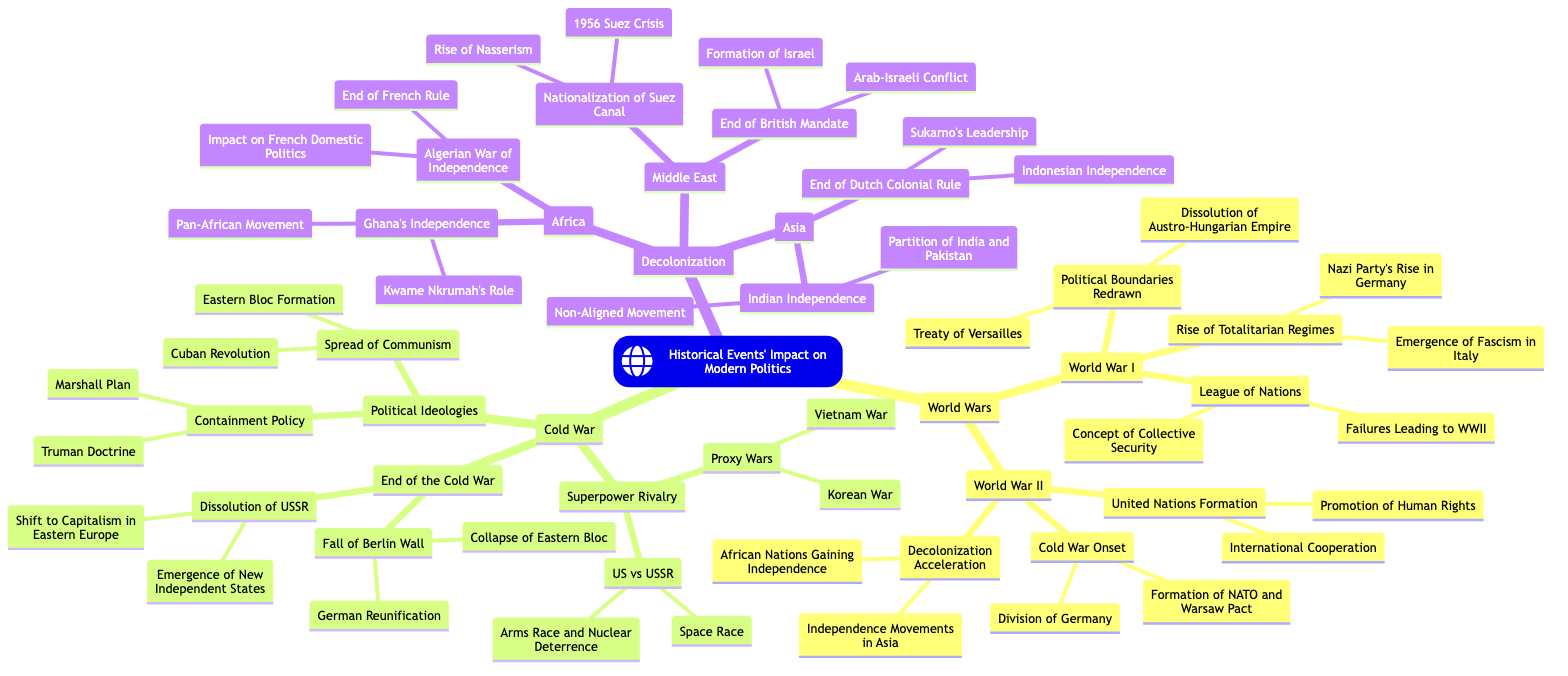What major treaty followed World War I? The diagram mentions that the "Treaty of Versailles" was a significant outcome of World War I under the branch "Political Boundaries Redrawn."
Answer: Treaty of Versailles What led to the formation of the United Nations? The diagram lists that the "United Nations Formation" was an outcome of World War II focusing on "International Cooperation" and the "Promotion of Human Rights."
Answer: United Nations Formation Which ideology spread significantly during the Cold War? The diagram states "Spread of Communism" as one of the key political ideologies during the Cold War.
Answer: Spread of Communism What was a major consequence of the dissolution of the USSR? The diagram indicates that the "Emergence of New Independent States" is a significant impact of the "Dissolution of USSR" in the context of the end of the Cold War.
Answer: Emergence of New Independent States How many major areas are covered under Decolonization? The diagram shows three main branches under Decolonization: Asia, Africa, and Middle East, totaling three areas.
Answer: 3 What movement was inspired by Ghana's independence? According to the diagram, Ghana's independence is linked to the "Pan-African Movement," reflecting the broader implications of decolonization in Africa.
Answer: Pan-African Movement What was the result of the Arab-Israeli Conflict? The diagram connects the "Arab-Israeli Conflict" to the outcome of the "Formation of Israel" after the End of the British Mandate in the Middle East.
Answer: Formation of Israel Which war was a proxy conflict during the Cold War? The diagram lists the "Vietnam War" as one of the key "Proxy Wars" associated with superpower rivalry between the US and USSR.
Answer: Vietnam War What event marked the beginning of the Cold War? The diagram suggests the "Cold War Onset" was an important outcome of World War II, including elements such as the "Division of Germany."
Answer: Cold War Onset 